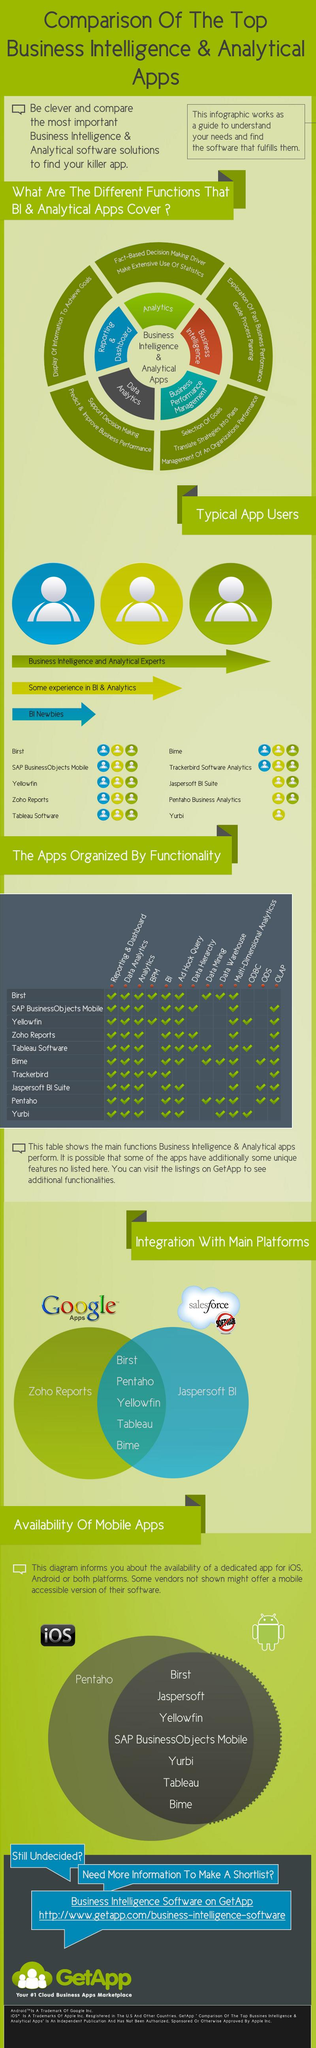Give some essential details in this illustration. Yurbi is designed to cater to users with some experience in BI & Analytics, providing them with the tools and functionality they need to gain insights from their data. Pentaho Business Analytics does not cater to users who are new to BI, specifically. Pentaho is the app that is only available for use on iOS devices A total of 7 apps do not have ODS. How many applications do not have both BI and Ad Hoc Query? 